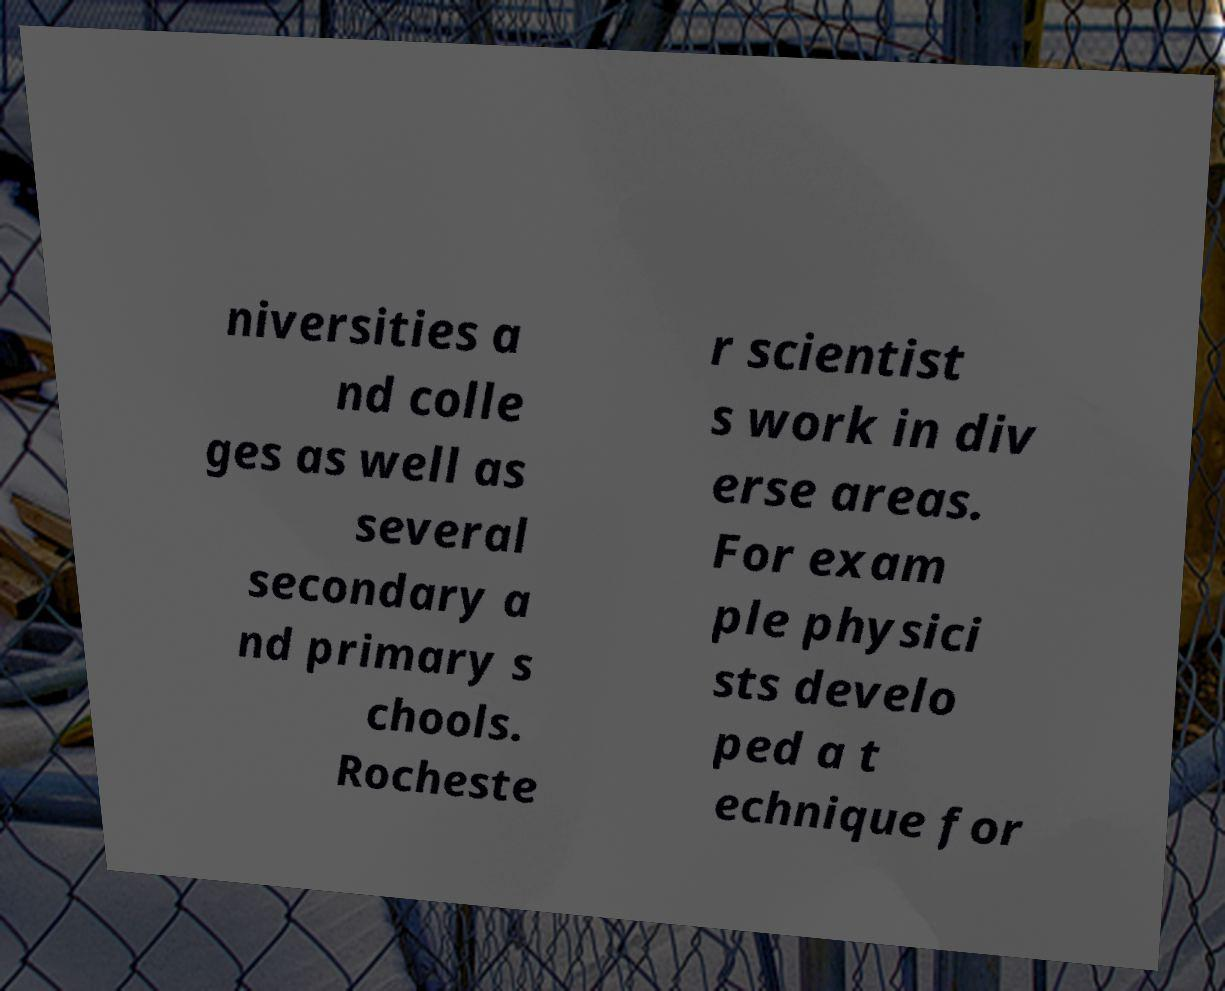For documentation purposes, I need the text within this image transcribed. Could you provide that? niversities a nd colle ges as well as several secondary a nd primary s chools. Rocheste r scientist s work in div erse areas. For exam ple physici sts develo ped a t echnique for 